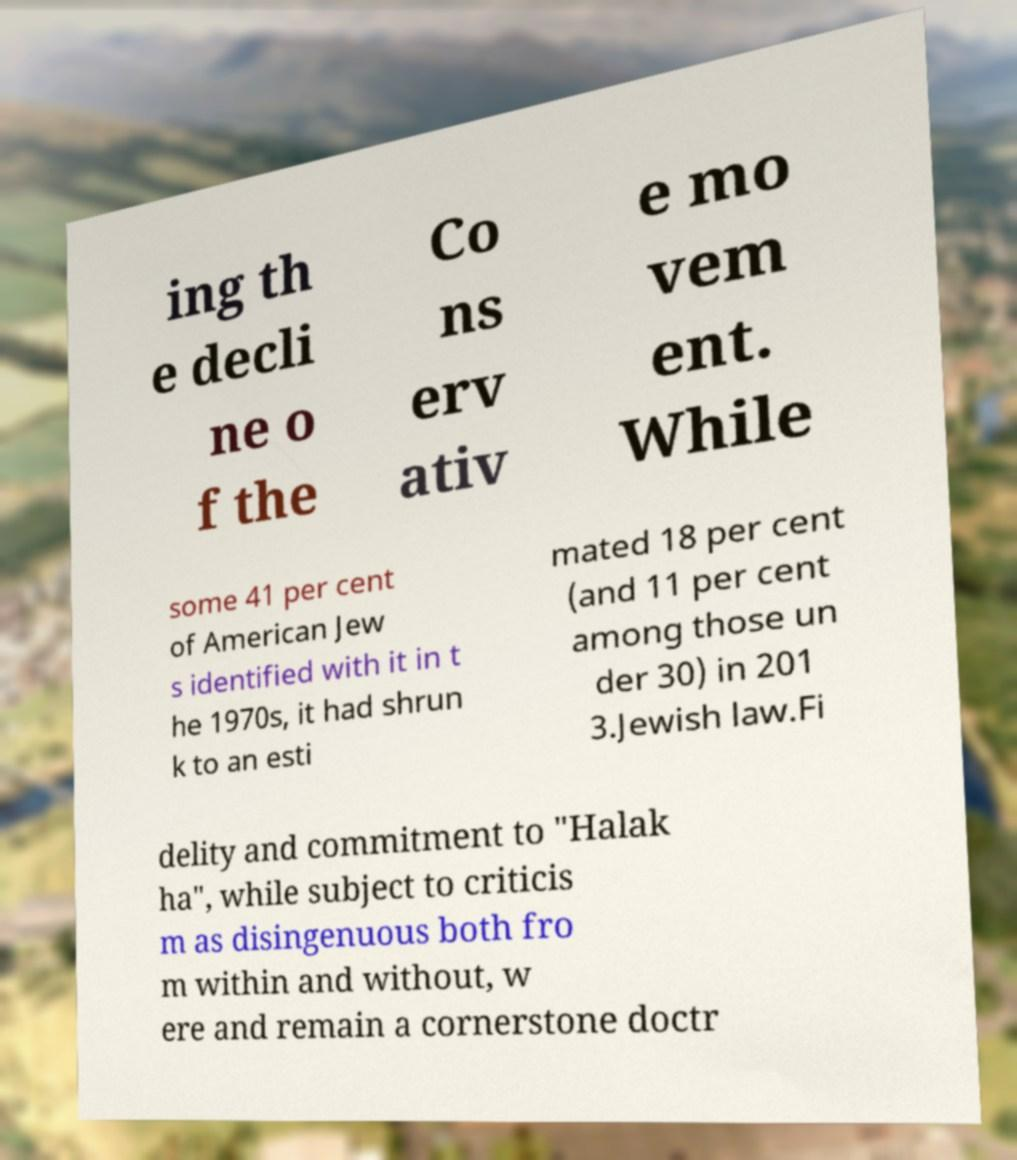Please identify and transcribe the text found in this image. ing th e decli ne o f the Co ns erv ativ e mo vem ent. While some 41 per cent of American Jew s identified with it in t he 1970s, it had shrun k to an esti mated 18 per cent (and 11 per cent among those un der 30) in 201 3.Jewish law.Fi delity and commitment to "Halak ha", while subject to criticis m as disingenuous both fro m within and without, w ere and remain a cornerstone doctr 